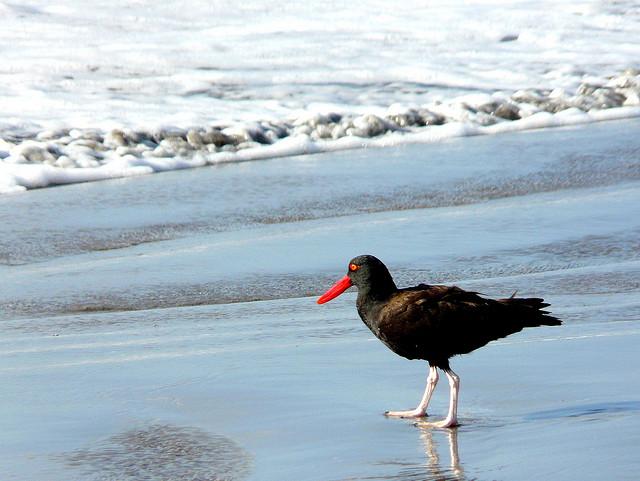What color is the bird's beak?
Be succinct. Red. Is this bird happy?
Write a very short answer. Yes. What type of bird is this?
Be succinct. Kingfisher. 